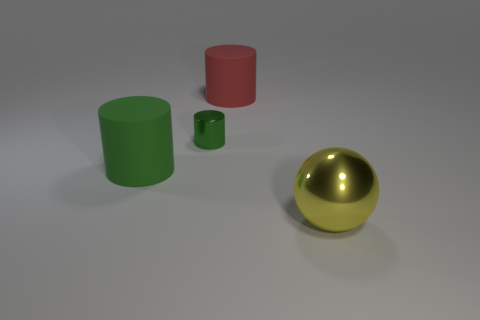Could you speculate on the material of the objects based on their appearance? Sure, the shiny cylinder and the sphere seem to have metallic surfaces, possibly steel or aluminum, while the matte cylinders resemble painted ceramics or plastics. 